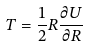Convert formula to latex. <formula><loc_0><loc_0><loc_500><loc_500>T = \frac { 1 } { 2 } R \frac { \partial U } { \partial R }</formula> 